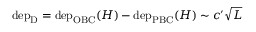Convert formula to latex. <formula><loc_0><loc_0><loc_500><loc_500>\begin{array} { r } { d e p _ { D } = d e p _ { O B C } ( H ) - d e p _ { P B C } ( H ) \sim c ^ { \prime } \sqrt { L } } \end{array}</formula> 